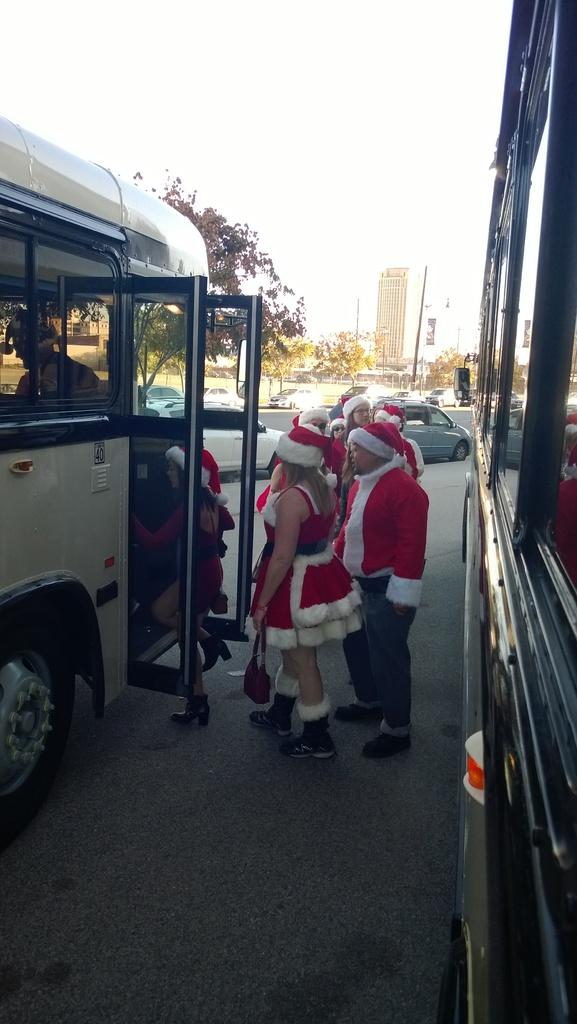What is happening in the image? There are people standing in the image, and there is a person inside a vehicle. What else can be seen on the road? There are vehicles visible on the road. What can be seen in the background of the image? There are trees, a building, and the sky visible in the background of the image. How many beds are visible in the image? There are no beds present in the image. What type of kitty can be seen playing with the people in the image? There is no kitty present in the image; only people and vehicles are visible. 